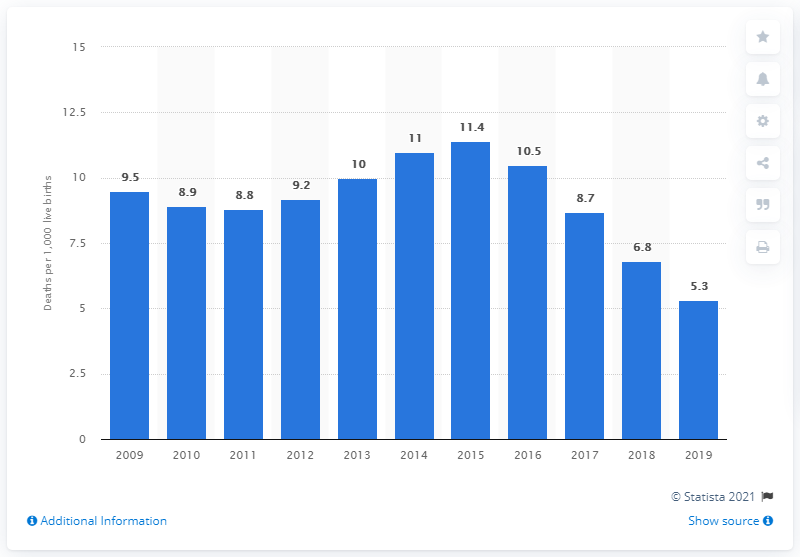Specify some key components in this picture. In 2019, the infant mortality rate in North Macedonia was 5.3 per 1,000 live births. 